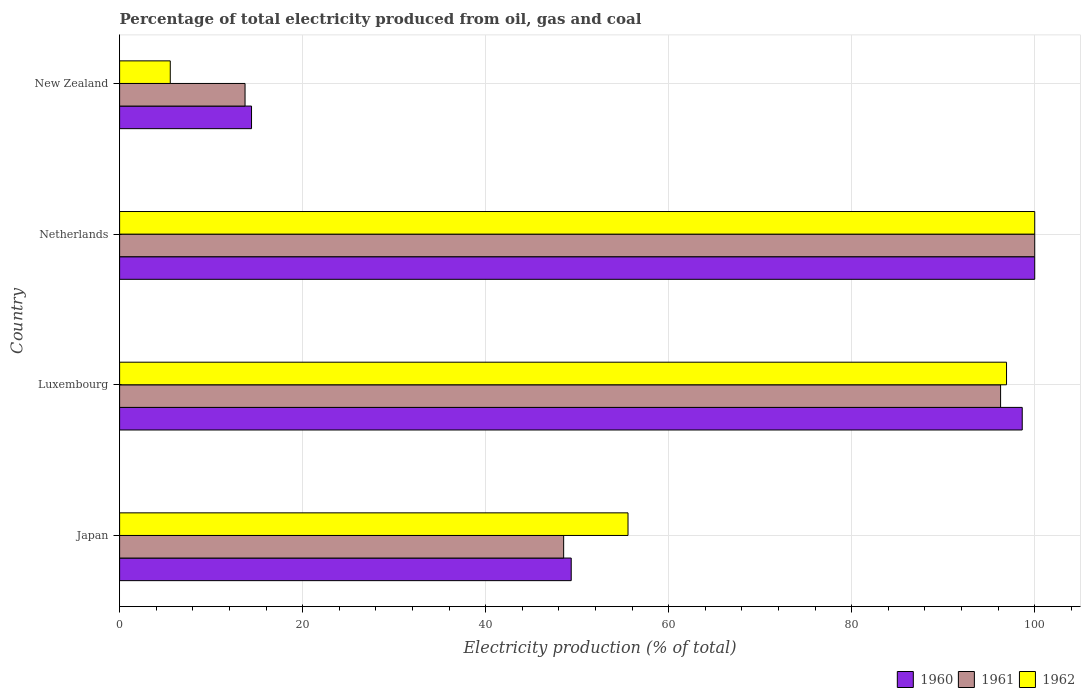How many groups of bars are there?
Your answer should be compact. 4. How many bars are there on the 1st tick from the top?
Make the answer very short. 3. How many bars are there on the 3rd tick from the bottom?
Offer a very short reply. 3. What is the label of the 1st group of bars from the top?
Your answer should be compact. New Zealand. What is the electricity production in in 1962 in Japan?
Make the answer very short. 55.56. Across all countries, what is the minimum electricity production in in 1960?
Your response must be concise. 14.42. In which country was the electricity production in in 1960 minimum?
Provide a succinct answer. New Zealand. What is the total electricity production in in 1960 in the graph?
Offer a terse response. 262.4. What is the difference between the electricity production in in 1960 in Japan and that in New Zealand?
Make the answer very short. 34.93. What is the difference between the electricity production in in 1960 in New Zealand and the electricity production in in 1961 in Netherlands?
Your response must be concise. -85.58. What is the average electricity production in in 1961 per country?
Your answer should be very brief. 64.63. What is the difference between the electricity production in in 1960 and electricity production in in 1962 in Netherlands?
Provide a short and direct response. 0. What is the ratio of the electricity production in in 1961 in Luxembourg to that in New Zealand?
Your answer should be compact. 7.02. What is the difference between the highest and the second highest electricity production in in 1961?
Offer a terse response. 3.73. What is the difference between the highest and the lowest electricity production in in 1960?
Offer a terse response. 85.58. In how many countries, is the electricity production in in 1960 greater than the average electricity production in in 1960 taken over all countries?
Offer a terse response. 2. Is the sum of the electricity production in in 1960 in Japan and New Zealand greater than the maximum electricity production in in 1962 across all countries?
Provide a succinct answer. No. What does the 1st bar from the top in Netherlands represents?
Offer a very short reply. 1962. How many bars are there?
Give a very brief answer. 12. Are all the bars in the graph horizontal?
Keep it short and to the point. Yes. How many countries are there in the graph?
Offer a terse response. 4. Are the values on the major ticks of X-axis written in scientific E-notation?
Your answer should be compact. No. How are the legend labels stacked?
Ensure brevity in your answer.  Horizontal. What is the title of the graph?
Offer a terse response. Percentage of total electricity produced from oil, gas and coal. What is the label or title of the X-axis?
Offer a very short reply. Electricity production (% of total). What is the Electricity production (% of total) of 1960 in Japan?
Keep it short and to the point. 49.35. What is the Electricity production (% of total) in 1961 in Japan?
Provide a short and direct response. 48.52. What is the Electricity production (% of total) of 1962 in Japan?
Your answer should be very brief. 55.56. What is the Electricity production (% of total) of 1960 in Luxembourg?
Provide a succinct answer. 98.63. What is the Electricity production (% of total) of 1961 in Luxembourg?
Ensure brevity in your answer.  96.27. What is the Electricity production (% of total) in 1962 in Luxembourg?
Your answer should be very brief. 96.92. What is the Electricity production (% of total) in 1960 in Netherlands?
Offer a terse response. 100. What is the Electricity production (% of total) of 1960 in New Zealand?
Your answer should be very brief. 14.42. What is the Electricity production (% of total) of 1961 in New Zealand?
Offer a terse response. 13.71. What is the Electricity production (% of total) of 1962 in New Zealand?
Your response must be concise. 5.54. Across all countries, what is the maximum Electricity production (% of total) of 1960?
Your answer should be very brief. 100. Across all countries, what is the minimum Electricity production (% of total) in 1960?
Provide a succinct answer. 14.42. Across all countries, what is the minimum Electricity production (% of total) in 1961?
Ensure brevity in your answer.  13.71. Across all countries, what is the minimum Electricity production (% of total) of 1962?
Give a very brief answer. 5.54. What is the total Electricity production (% of total) of 1960 in the graph?
Your response must be concise. 262.4. What is the total Electricity production (% of total) of 1961 in the graph?
Offer a terse response. 258.5. What is the total Electricity production (% of total) in 1962 in the graph?
Offer a terse response. 258.01. What is the difference between the Electricity production (% of total) of 1960 in Japan and that in Luxembourg?
Your answer should be compact. -49.28. What is the difference between the Electricity production (% of total) of 1961 in Japan and that in Luxembourg?
Give a very brief answer. -47.75. What is the difference between the Electricity production (% of total) in 1962 in Japan and that in Luxembourg?
Offer a very short reply. -41.36. What is the difference between the Electricity production (% of total) of 1960 in Japan and that in Netherlands?
Offer a terse response. -50.65. What is the difference between the Electricity production (% of total) of 1961 in Japan and that in Netherlands?
Offer a very short reply. -51.48. What is the difference between the Electricity production (% of total) of 1962 in Japan and that in Netherlands?
Offer a very short reply. -44.44. What is the difference between the Electricity production (% of total) in 1960 in Japan and that in New Zealand?
Your response must be concise. 34.93. What is the difference between the Electricity production (% of total) of 1961 in Japan and that in New Zealand?
Your response must be concise. 34.82. What is the difference between the Electricity production (% of total) in 1962 in Japan and that in New Zealand?
Your answer should be very brief. 50.02. What is the difference between the Electricity production (% of total) of 1960 in Luxembourg and that in Netherlands?
Provide a succinct answer. -1.37. What is the difference between the Electricity production (% of total) of 1961 in Luxembourg and that in Netherlands?
Provide a short and direct response. -3.73. What is the difference between the Electricity production (% of total) in 1962 in Luxembourg and that in Netherlands?
Give a very brief answer. -3.08. What is the difference between the Electricity production (% of total) of 1960 in Luxembourg and that in New Zealand?
Offer a terse response. 84.22. What is the difference between the Electricity production (% of total) in 1961 in Luxembourg and that in New Zealand?
Ensure brevity in your answer.  82.56. What is the difference between the Electricity production (% of total) of 1962 in Luxembourg and that in New Zealand?
Your answer should be very brief. 91.38. What is the difference between the Electricity production (% of total) of 1960 in Netherlands and that in New Zealand?
Make the answer very short. 85.58. What is the difference between the Electricity production (% of total) of 1961 in Netherlands and that in New Zealand?
Your answer should be very brief. 86.29. What is the difference between the Electricity production (% of total) in 1962 in Netherlands and that in New Zealand?
Offer a very short reply. 94.46. What is the difference between the Electricity production (% of total) in 1960 in Japan and the Electricity production (% of total) in 1961 in Luxembourg?
Your response must be concise. -46.92. What is the difference between the Electricity production (% of total) in 1960 in Japan and the Electricity production (% of total) in 1962 in Luxembourg?
Offer a terse response. -47.57. What is the difference between the Electricity production (% of total) of 1961 in Japan and the Electricity production (% of total) of 1962 in Luxembourg?
Your answer should be very brief. -48.39. What is the difference between the Electricity production (% of total) in 1960 in Japan and the Electricity production (% of total) in 1961 in Netherlands?
Offer a terse response. -50.65. What is the difference between the Electricity production (% of total) of 1960 in Japan and the Electricity production (% of total) of 1962 in Netherlands?
Give a very brief answer. -50.65. What is the difference between the Electricity production (% of total) of 1961 in Japan and the Electricity production (% of total) of 1962 in Netherlands?
Make the answer very short. -51.48. What is the difference between the Electricity production (% of total) of 1960 in Japan and the Electricity production (% of total) of 1961 in New Zealand?
Ensure brevity in your answer.  35.64. What is the difference between the Electricity production (% of total) of 1960 in Japan and the Electricity production (% of total) of 1962 in New Zealand?
Your answer should be very brief. 43.81. What is the difference between the Electricity production (% of total) in 1961 in Japan and the Electricity production (% of total) in 1962 in New Zealand?
Your response must be concise. 42.99. What is the difference between the Electricity production (% of total) of 1960 in Luxembourg and the Electricity production (% of total) of 1961 in Netherlands?
Provide a short and direct response. -1.37. What is the difference between the Electricity production (% of total) in 1960 in Luxembourg and the Electricity production (% of total) in 1962 in Netherlands?
Make the answer very short. -1.37. What is the difference between the Electricity production (% of total) of 1961 in Luxembourg and the Electricity production (% of total) of 1962 in Netherlands?
Offer a terse response. -3.73. What is the difference between the Electricity production (% of total) in 1960 in Luxembourg and the Electricity production (% of total) in 1961 in New Zealand?
Provide a short and direct response. 84.93. What is the difference between the Electricity production (% of total) of 1960 in Luxembourg and the Electricity production (% of total) of 1962 in New Zealand?
Your answer should be very brief. 93.1. What is the difference between the Electricity production (% of total) of 1961 in Luxembourg and the Electricity production (% of total) of 1962 in New Zealand?
Keep it short and to the point. 90.73. What is the difference between the Electricity production (% of total) of 1960 in Netherlands and the Electricity production (% of total) of 1961 in New Zealand?
Offer a very short reply. 86.29. What is the difference between the Electricity production (% of total) in 1960 in Netherlands and the Electricity production (% of total) in 1962 in New Zealand?
Your answer should be compact. 94.46. What is the difference between the Electricity production (% of total) in 1961 in Netherlands and the Electricity production (% of total) in 1962 in New Zealand?
Your response must be concise. 94.46. What is the average Electricity production (% of total) of 1960 per country?
Offer a very short reply. 65.6. What is the average Electricity production (% of total) of 1961 per country?
Provide a short and direct response. 64.63. What is the average Electricity production (% of total) in 1962 per country?
Offer a very short reply. 64.5. What is the difference between the Electricity production (% of total) of 1960 and Electricity production (% of total) of 1961 in Japan?
Your answer should be very brief. 0.83. What is the difference between the Electricity production (% of total) of 1960 and Electricity production (% of total) of 1962 in Japan?
Make the answer very short. -6.2. What is the difference between the Electricity production (% of total) in 1961 and Electricity production (% of total) in 1962 in Japan?
Give a very brief answer. -7.03. What is the difference between the Electricity production (% of total) of 1960 and Electricity production (% of total) of 1961 in Luxembourg?
Provide a succinct answer. 2.36. What is the difference between the Electricity production (% of total) of 1960 and Electricity production (% of total) of 1962 in Luxembourg?
Provide a succinct answer. 1.72. What is the difference between the Electricity production (% of total) in 1961 and Electricity production (% of total) in 1962 in Luxembourg?
Your response must be concise. -0.65. What is the difference between the Electricity production (% of total) in 1960 and Electricity production (% of total) in 1961 in Netherlands?
Offer a terse response. 0. What is the difference between the Electricity production (% of total) in 1960 and Electricity production (% of total) in 1961 in New Zealand?
Your answer should be compact. 0.71. What is the difference between the Electricity production (% of total) in 1960 and Electricity production (% of total) in 1962 in New Zealand?
Give a very brief answer. 8.88. What is the difference between the Electricity production (% of total) of 1961 and Electricity production (% of total) of 1962 in New Zealand?
Make the answer very short. 8.17. What is the ratio of the Electricity production (% of total) of 1960 in Japan to that in Luxembourg?
Offer a terse response. 0.5. What is the ratio of the Electricity production (% of total) in 1961 in Japan to that in Luxembourg?
Provide a succinct answer. 0.5. What is the ratio of the Electricity production (% of total) of 1962 in Japan to that in Luxembourg?
Your answer should be very brief. 0.57. What is the ratio of the Electricity production (% of total) of 1960 in Japan to that in Netherlands?
Offer a terse response. 0.49. What is the ratio of the Electricity production (% of total) of 1961 in Japan to that in Netherlands?
Offer a terse response. 0.49. What is the ratio of the Electricity production (% of total) in 1962 in Japan to that in Netherlands?
Provide a short and direct response. 0.56. What is the ratio of the Electricity production (% of total) of 1960 in Japan to that in New Zealand?
Offer a terse response. 3.42. What is the ratio of the Electricity production (% of total) of 1961 in Japan to that in New Zealand?
Your answer should be compact. 3.54. What is the ratio of the Electricity production (% of total) in 1962 in Japan to that in New Zealand?
Your response must be concise. 10.03. What is the ratio of the Electricity production (% of total) in 1960 in Luxembourg to that in Netherlands?
Make the answer very short. 0.99. What is the ratio of the Electricity production (% of total) in 1961 in Luxembourg to that in Netherlands?
Offer a terse response. 0.96. What is the ratio of the Electricity production (% of total) of 1962 in Luxembourg to that in Netherlands?
Provide a succinct answer. 0.97. What is the ratio of the Electricity production (% of total) in 1960 in Luxembourg to that in New Zealand?
Offer a very short reply. 6.84. What is the ratio of the Electricity production (% of total) in 1961 in Luxembourg to that in New Zealand?
Your response must be concise. 7.02. What is the ratio of the Electricity production (% of total) in 1962 in Luxembourg to that in New Zealand?
Make the answer very short. 17.51. What is the ratio of the Electricity production (% of total) in 1960 in Netherlands to that in New Zealand?
Provide a succinct answer. 6.94. What is the ratio of the Electricity production (% of total) of 1961 in Netherlands to that in New Zealand?
Provide a short and direct response. 7.29. What is the ratio of the Electricity production (% of total) in 1962 in Netherlands to that in New Zealand?
Provide a succinct answer. 18.06. What is the difference between the highest and the second highest Electricity production (% of total) of 1960?
Your answer should be compact. 1.37. What is the difference between the highest and the second highest Electricity production (% of total) of 1961?
Give a very brief answer. 3.73. What is the difference between the highest and the second highest Electricity production (% of total) of 1962?
Your answer should be compact. 3.08. What is the difference between the highest and the lowest Electricity production (% of total) of 1960?
Make the answer very short. 85.58. What is the difference between the highest and the lowest Electricity production (% of total) in 1961?
Provide a succinct answer. 86.29. What is the difference between the highest and the lowest Electricity production (% of total) of 1962?
Ensure brevity in your answer.  94.46. 